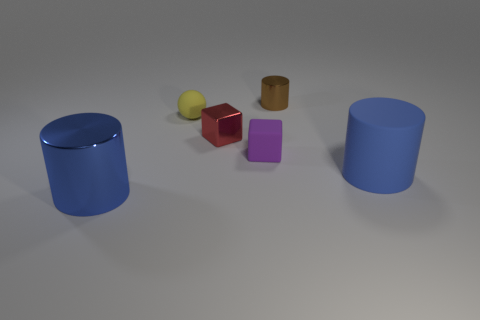Subtract all blue cubes. Subtract all red cylinders. How many cubes are left? 2 Add 2 brown objects. How many objects exist? 8 Subtract all spheres. How many objects are left? 5 Add 5 big blue rubber cylinders. How many big blue rubber cylinders are left? 6 Add 3 brown shiny things. How many brown shiny things exist? 4 Subtract 0 green blocks. How many objects are left? 6 Subtract all objects. Subtract all small yellow matte blocks. How many objects are left? 0 